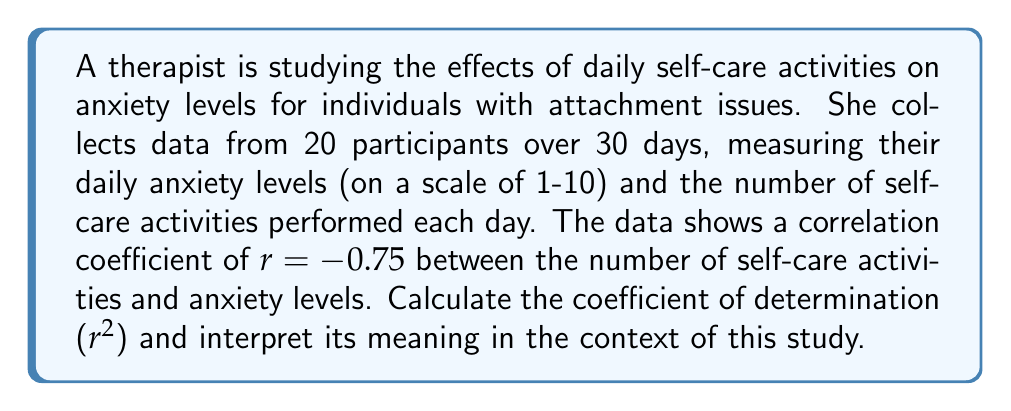Can you answer this question? 1. The correlation coefficient $r$ is given as -0.75.

2. The coefficient of determination, $r^2$, is calculated by squaring the correlation coefficient:

   $$r^2 = (-0.75)^2 = 0.5625$$

3. To interpret $r^2$:
   - $r^2$ represents the proportion of variance in the dependent variable (anxiety levels) that can be explained by the independent variable (number of self-care activities).
   - Multiply $r^2$ by 100 to get the percentage: $0.5625 \times 100 = 56.25\%$

4. Interpretation: 56.25% of the variation in anxiety levels can be explained by the number of self-care activities performed.

5. In the context of the study:
   - This suggests a moderate to strong relationship between self-care activities and anxiety levels for individuals with attachment issues.
   - It indicates that engaging in self-care activities may have a substantial impact on reducing anxiety levels for these individuals.
   - However, it also implies that 43.75% of the variation in anxiety levels is due to other factors not accounted for in this model.
Answer: $r^2 = 0.5625$; 56.25% of anxiety level variation is explained by self-care activities. 